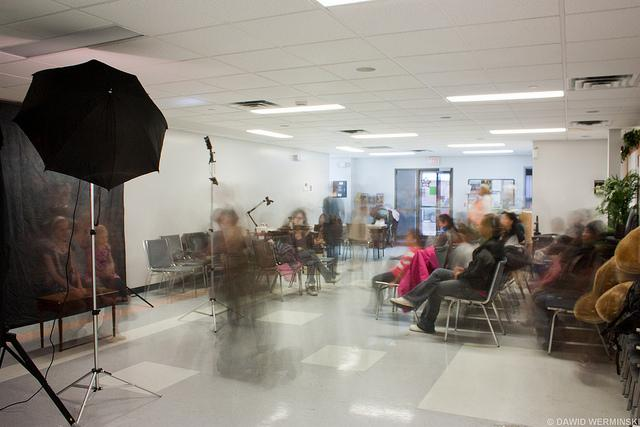What is the umbrella being used for? Please explain your reasoning. lighting. The umbrella is used for photographic lighting. 